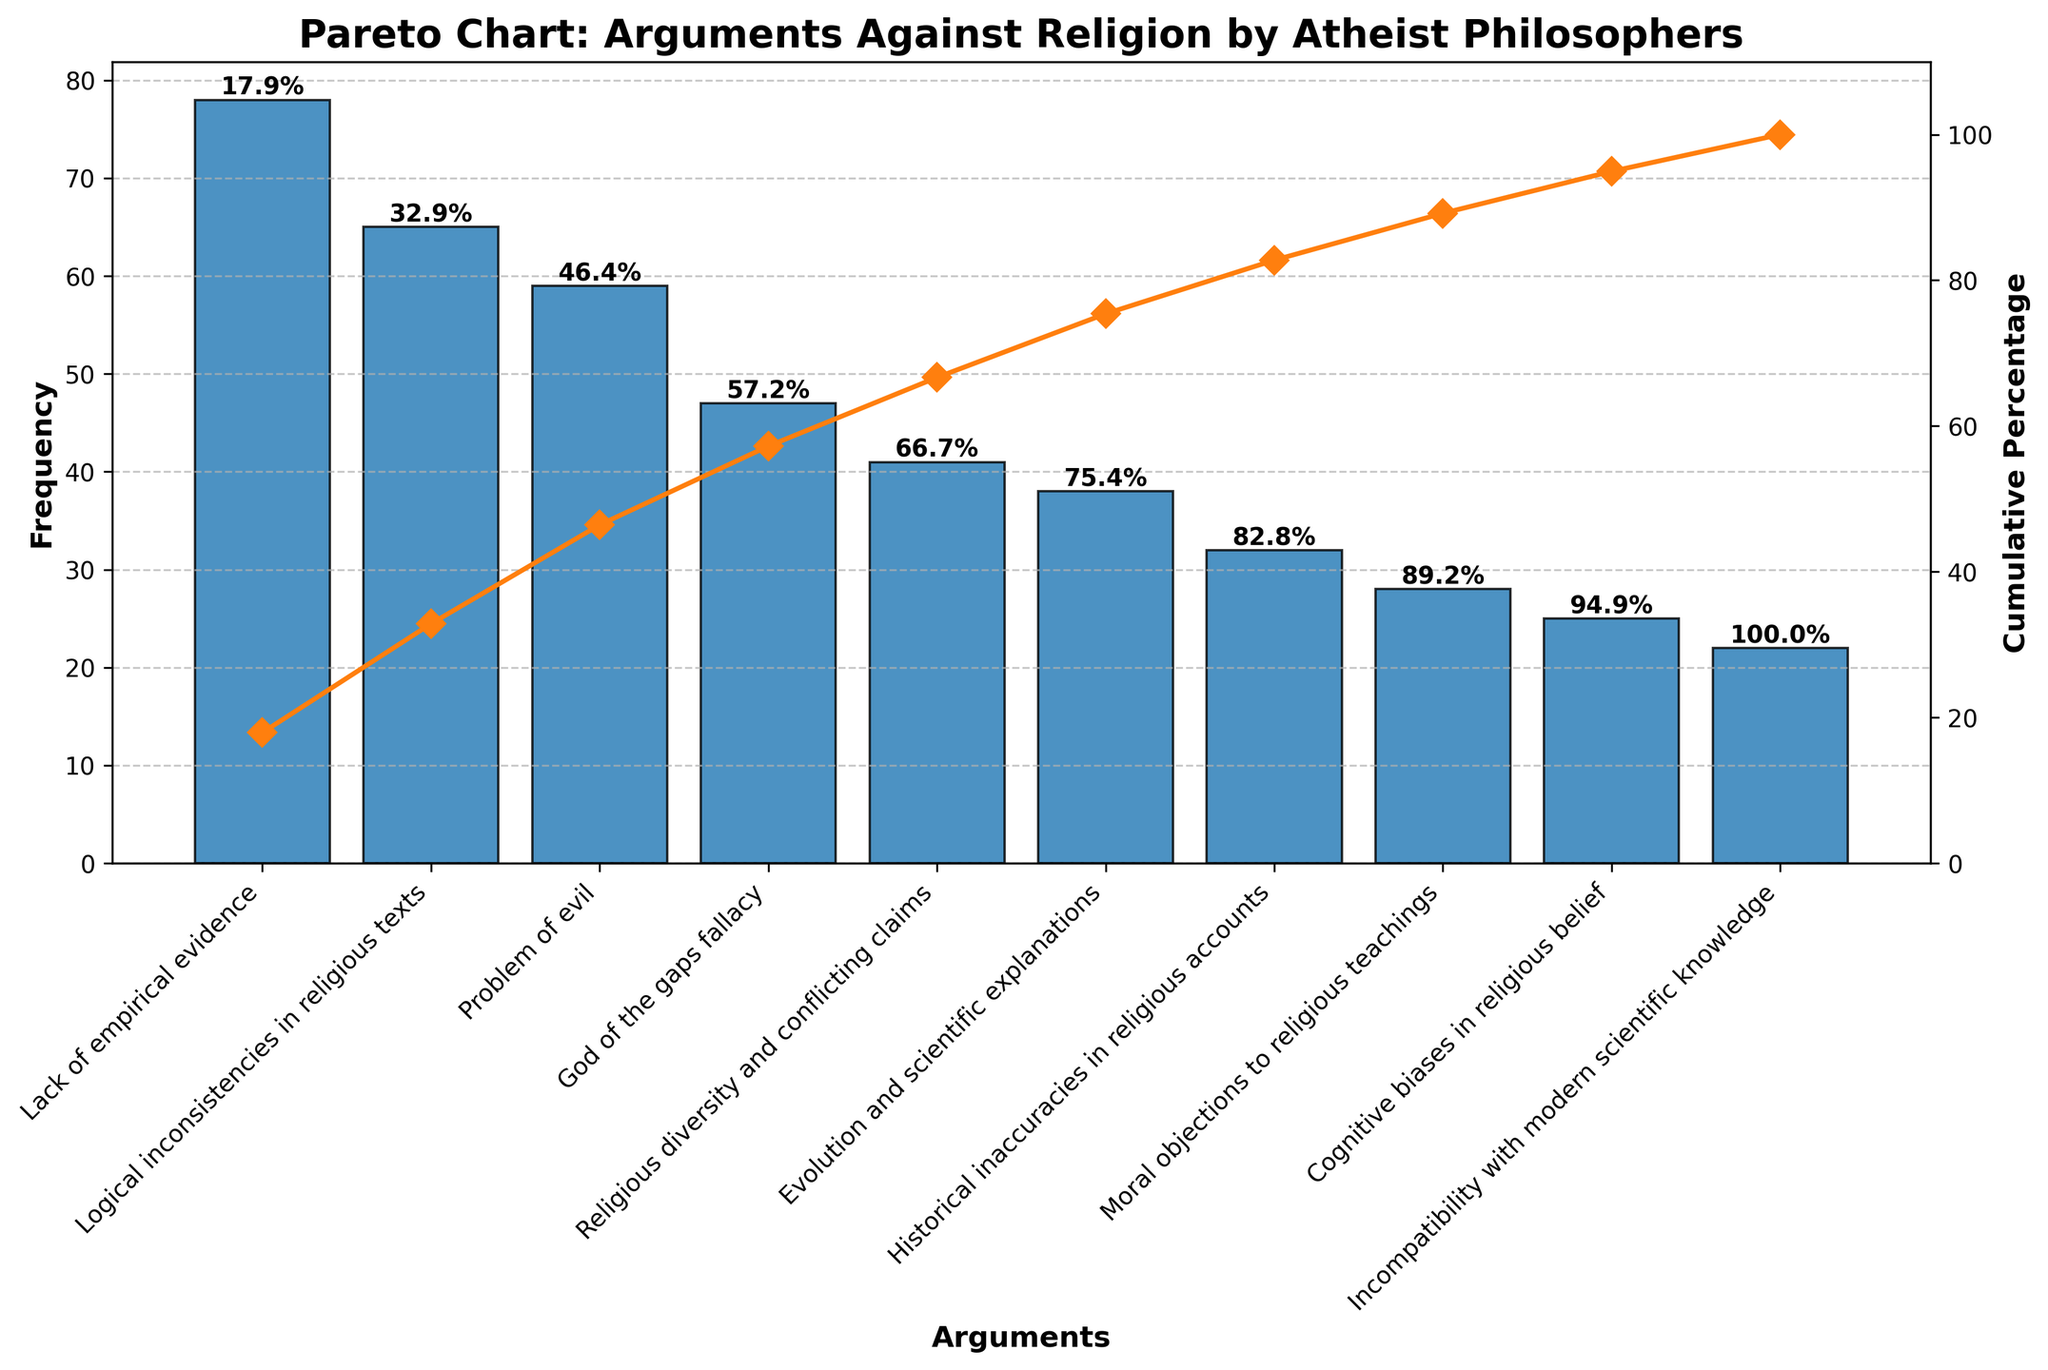What is the title of the figure? The title is usually found at the top of the figure. In this case, the title is clear at the top of the Pareto chart.
Answer: Pareto Chart: Arguments Against Religion by Atheist Philosophers Which argument has the highest frequency? The argument with the highest frequency is represented by the tallest bar on the chart, which is the first one.
Answer: Lack of empirical evidence What cumulative percentage does the 'Problem of evil' argument reach? Locate the bar for 'Problem of evil', then find the corresponding point on the cumulative line plot and read off the value. The cumulative percentage labels on top of bars also help.
Answer: 59% How many arguments have more than 50 frequencies? Count the bars whose heights are above 50 on the frequency axis. These are the first three bars: 'Lack of empirical evidence', 'Logical inconsistencies in religious texts', and 'Problem of evil'.
Answer: 3 What percentage of the total frequency does 'God of the gaps fallacy' contribute? The cumulative percentage for 'God of the gaps fallacy' is read from the chart. It's the last percentage before the 4th bar ('Religious diversity and conflicting claims').
Answer: 80% Which argument has a frequency closest to 25? Find the bars and locate the one close to 25 on the frequency axis, which is 'Cognitive biases in religious belief' with a frequency of 25.
Answer: Cognitive biases in religious belief What is the cumulative percentage after the three most cited arguments? Identify the three most cited arguments and read the cumulative percentage at the top of the third bar ('Problem of evil').
Answer: 65% Compare the frequencies of 'Historical inaccuracies in religious accounts' and 'Moral objections to religious teachings'. Which one is higher? Compare the heights of the corresponding bars on the chart. The bar for 'Historical inaccuracies in religious accounts' is taller than 'Moral objections to religious teachings'.
Answer: Historical inaccuracies in religious accounts What is the sum of frequencies for 'Evolution and scientific explanations' and 'Cognitive biases in religious belief'? Find the frequencies from the corresponding bars: 'Evolution and scientific explanations' (38) and 'Cognitive biases in religious belief' (25). Sum them up: 38 + 25 = 63.
Answer: 63 What argument is represented by the last bar in the chart and what is its frequency? The last bar can be found by reading the argument label for the farthest right bar on the chart, which is 'Incompatibility with modern scientific knowledge'. Its frequency is the height of this bar, which is 22.
Answer: Incompatibility with modern scientific knowledge, 22 